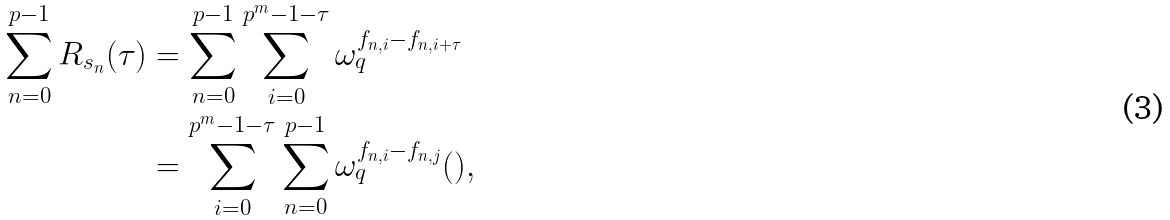<formula> <loc_0><loc_0><loc_500><loc_500>\sum _ { n = 0 } ^ { p - 1 } R _ { s _ { n } } ( \tau ) & = \sum _ { n = 0 } ^ { p - 1 } \sum _ { i = 0 } ^ { p ^ { m } - 1 - \tau } \omega _ { q } ^ { f _ { n , i } - f _ { n , i + \tau } } \\ & = \sum _ { i = 0 } ^ { p ^ { m } - 1 - \tau } \sum _ { n = 0 } ^ { p - 1 } \omega _ { q } ^ { f _ { n , i } - f _ { n , j } } ( ) ,</formula> 